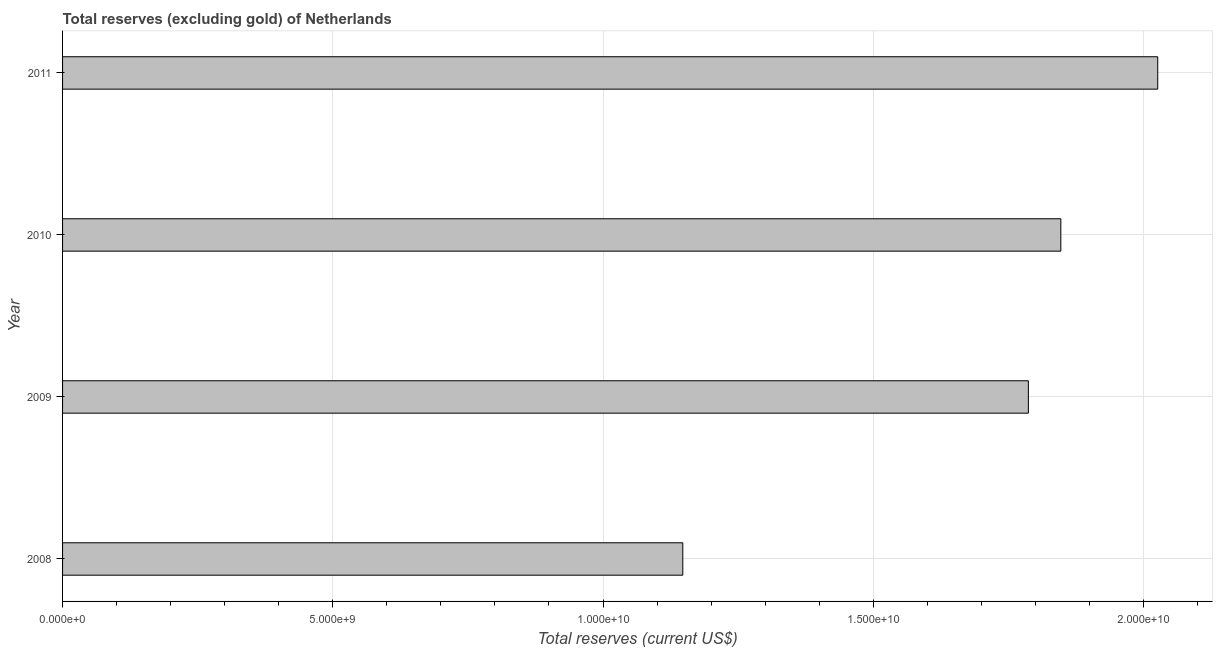Does the graph contain any zero values?
Your response must be concise. No. What is the title of the graph?
Your answer should be very brief. Total reserves (excluding gold) of Netherlands. What is the label or title of the X-axis?
Provide a short and direct response. Total reserves (current US$). What is the label or title of the Y-axis?
Your response must be concise. Year. What is the total reserves (excluding gold) in 2010?
Give a very brief answer. 1.85e+1. Across all years, what is the maximum total reserves (excluding gold)?
Provide a short and direct response. 2.03e+1. Across all years, what is the minimum total reserves (excluding gold)?
Provide a short and direct response. 1.15e+1. In which year was the total reserves (excluding gold) maximum?
Keep it short and to the point. 2011. In which year was the total reserves (excluding gold) minimum?
Your response must be concise. 2008. What is the sum of the total reserves (excluding gold)?
Your answer should be very brief. 6.81e+1. What is the difference between the total reserves (excluding gold) in 2008 and 2011?
Your answer should be very brief. -8.79e+09. What is the average total reserves (excluding gold) per year?
Offer a terse response. 1.70e+1. What is the median total reserves (excluding gold)?
Your answer should be very brief. 1.82e+1. In how many years, is the total reserves (excluding gold) greater than 10000000000 US$?
Your answer should be compact. 4. Do a majority of the years between 2009 and 2011 (inclusive) have total reserves (excluding gold) greater than 5000000000 US$?
Keep it short and to the point. Yes. What is the ratio of the total reserves (excluding gold) in 2008 to that in 2011?
Make the answer very short. 0.57. Is the difference between the total reserves (excluding gold) in 2008 and 2009 greater than the difference between any two years?
Your answer should be very brief. No. What is the difference between the highest and the second highest total reserves (excluding gold)?
Give a very brief answer. 1.79e+09. Is the sum of the total reserves (excluding gold) in 2009 and 2011 greater than the maximum total reserves (excluding gold) across all years?
Provide a succinct answer. Yes. What is the difference between the highest and the lowest total reserves (excluding gold)?
Offer a very short reply. 8.79e+09. How many bars are there?
Provide a succinct answer. 4. What is the difference between two consecutive major ticks on the X-axis?
Keep it short and to the point. 5.00e+09. Are the values on the major ticks of X-axis written in scientific E-notation?
Make the answer very short. Yes. What is the Total reserves (current US$) of 2008?
Your response must be concise. 1.15e+1. What is the Total reserves (current US$) in 2009?
Keep it short and to the point. 1.79e+1. What is the Total reserves (current US$) of 2010?
Ensure brevity in your answer.  1.85e+1. What is the Total reserves (current US$) in 2011?
Give a very brief answer. 2.03e+1. What is the difference between the Total reserves (current US$) in 2008 and 2009?
Offer a terse response. -6.39e+09. What is the difference between the Total reserves (current US$) in 2008 and 2010?
Give a very brief answer. -6.99e+09. What is the difference between the Total reserves (current US$) in 2008 and 2011?
Your answer should be very brief. -8.79e+09. What is the difference between the Total reserves (current US$) in 2009 and 2010?
Your answer should be compact. -6.01e+08. What is the difference between the Total reserves (current US$) in 2009 and 2011?
Your answer should be compact. -2.39e+09. What is the difference between the Total reserves (current US$) in 2010 and 2011?
Offer a very short reply. -1.79e+09. What is the ratio of the Total reserves (current US$) in 2008 to that in 2009?
Ensure brevity in your answer.  0.64. What is the ratio of the Total reserves (current US$) in 2008 to that in 2010?
Make the answer very short. 0.62. What is the ratio of the Total reserves (current US$) in 2008 to that in 2011?
Keep it short and to the point. 0.57. What is the ratio of the Total reserves (current US$) in 2009 to that in 2011?
Your answer should be very brief. 0.88. What is the ratio of the Total reserves (current US$) in 2010 to that in 2011?
Give a very brief answer. 0.91. 